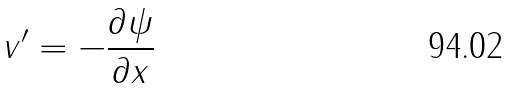Convert formula to latex. <formula><loc_0><loc_0><loc_500><loc_500>v ^ { \prime } = - \frac { \partial \psi } { \partial x }</formula> 